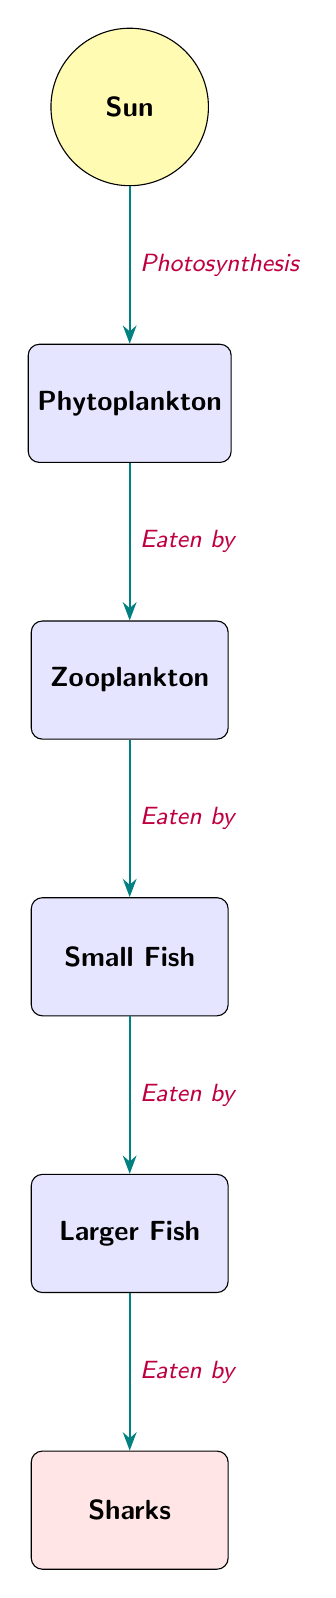What is the first node in the food chain? The diagram shows the food chain starting with the Sun, which is the first node.
Answer: Sun How many nodes are present in the diagram? The nodes include Sun, Phytoplankton, Zooplankton, Small Fish, Larger Fish, and Sharks, totaling six nodes.
Answer: 6 What process connects the Sun to Phytoplankton? The relationship is defined as Photosynthesis, indicating how energy is transferred from the Sun to Phytoplankton.
Answer: Photosynthesis What do Zooplankton eat? The diagram indicates that Zooplankton eat Phytoplankton, which is reflected in the flow direction.
Answer: Phytoplankton Which organism is the apex predator in this ecosystem? The apex predator is defined as Sharks in the diagram, which are at the top of the food chain.
Answer: Sharks What is the last link in the food chain? The last link indicates the final node, which is Sharks; they are the ultimate consumers in this chain.
Answer: Sharks How many times does the term "Eaten by" appear in the diagram? The "Eaten by" phrase appears four times: from Phytoplankton to Zooplankton, from Zooplankton to Small Fish, from Small Fish to Larger Fish, and from Larger Fish to Sharks.
Answer: 4 Which organism is directly above Small Fish in the food chain? The diagram shows that Larger Fish is the organism directly above Small Fish, indicating a predator-prey relationship.
Answer: Larger Fish Which two organisms are considered primary consumers in this marine ecosystem? The primary consumers in the diagram are Phytoplankton and Zooplankton, as they directly consume the energy from the Sun.
Answer: Phytoplankton, Zooplankton 